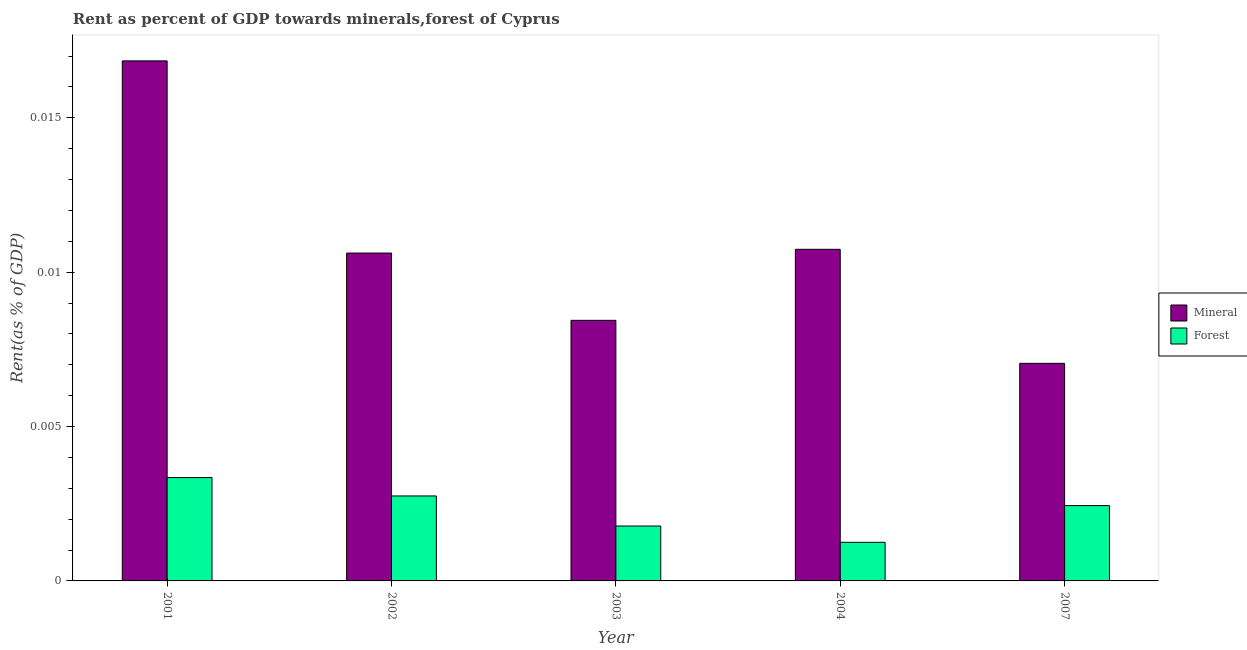How many groups of bars are there?
Offer a very short reply. 5. Are the number of bars per tick equal to the number of legend labels?
Offer a terse response. Yes. What is the label of the 5th group of bars from the left?
Your answer should be compact. 2007. What is the mineral rent in 2004?
Offer a terse response. 0.01. Across all years, what is the maximum forest rent?
Provide a succinct answer. 0. Across all years, what is the minimum mineral rent?
Offer a terse response. 0.01. In which year was the forest rent maximum?
Provide a succinct answer. 2001. In which year was the mineral rent minimum?
Keep it short and to the point. 2007. What is the total mineral rent in the graph?
Keep it short and to the point. 0.05. What is the difference between the forest rent in 2004 and that in 2007?
Provide a succinct answer. -0. What is the difference between the mineral rent in 2002 and the forest rent in 2003?
Ensure brevity in your answer.  0. What is the average mineral rent per year?
Your answer should be very brief. 0.01. In the year 2001, what is the difference between the forest rent and mineral rent?
Your answer should be very brief. 0. In how many years, is the mineral rent greater than 0.005 %?
Keep it short and to the point. 5. What is the ratio of the forest rent in 2001 to that in 2002?
Make the answer very short. 1.22. What is the difference between the highest and the second highest mineral rent?
Provide a short and direct response. 0.01. What is the difference between the highest and the lowest mineral rent?
Offer a terse response. 0.01. In how many years, is the forest rent greater than the average forest rent taken over all years?
Your response must be concise. 3. Is the sum of the mineral rent in 2002 and 2007 greater than the maximum forest rent across all years?
Your answer should be compact. Yes. What does the 1st bar from the left in 2007 represents?
Your answer should be very brief. Mineral. What does the 2nd bar from the right in 2007 represents?
Ensure brevity in your answer.  Mineral. Are all the bars in the graph horizontal?
Your answer should be very brief. No. How many years are there in the graph?
Your answer should be very brief. 5. What is the difference between two consecutive major ticks on the Y-axis?
Your answer should be very brief. 0.01. Are the values on the major ticks of Y-axis written in scientific E-notation?
Ensure brevity in your answer.  No. How are the legend labels stacked?
Your response must be concise. Vertical. What is the title of the graph?
Provide a short and direct response. Rent as percent of GDP towards minerals,forest of Cyprus. Does "Death rate" appear as one of the legend labels in the graph?
Provide a short and direct response. No. What is the label or title of the Y-axis?
Make the answer very short. Rent(as % of GDP). What is the Rent(as % of GDP) of Mineral in 2001?
Offer a very short reply. 0.02. What is the Rent(as % of GDP) in Forest in 2001?
Provide a short and direct response. 0. What is the Rent(as % of GDP) of Mineral in 2002?
Your answer should be compact. 0.01. What is the Rent(as % of GDP) of Forest in 2002?
Keep it short and to the point. 0. What is the Rent(as % of GDP) in Mineral in 2003?
Offer a terse response. 0.01. What is the Rent(as % of GDP) of Forest in 2003?
Your answer should be compact. 0. What is the Rent(as % of GDP) of Mineral in 2004?
Offer a very short reply. 0.01. What is the Rent(as % of GDP) in Forest in 2004?
Your response must be concise. 0. What is the Rent(as % of GDP) of Mineral in 2007?
Keep it short and to the point. 0.01. What is the Rent(as % of GDP) of Forest in 2007?
Provide a succinct answer. 0. Across all years, what is the maximum Rent(as % of GDP) of Mineral?
Keep it short and to the point. 0.02. Across all years, what is the maximum Rent(as % of GDP) in Forest?
Provide a short and direct response. 0. Across all years, what is the minimum Rent(as % of GDP) in Mineral?
Offer a terse response. 0.01. Across all years, what is the minimum Rent(as % of GDP) of Forest?
Make the answer very short. 0. What is the total Rent(as % of GDP) of Mineral in the graph?
Make the answer very short. 0.05. What is the total Rent(as % of GDP) of Forest in the graph?
Make the answer very short. 0.01. What is the difference between the Rent(as % of GDP) of Mineral in 2001 and that in 2002?
Make the answer very short. 0.01. What is the difference between the Rent(as % of GDP) of Forest in 2001 and that in 2002?
Ensure brevity in your answer.  0. What is the difference between the Rent(as % of GDP) in Mineral in 2001 and that in 2003?
Make the answer very short. 0.01. What is the difference between the Rent(as % of GDP) of Forest in 2001 and that in 2003?
Your answer should be compact. 0. What is the difference between the Rent(as % of GDP) in Mineral in 2001 and that in 2004?
Your answer should be compact. 0.01. What is the difference between the Rent(as % of GDP) of Forest in 2001 and that in 2004?
Offer a very short reply. 0. What is the difference between the Rent(as % of GDP) of Mineral in 2001 and that in 2007?
Offer a terse response. 0.01. What is the difference between the Rent(as % of GDP) of Forest in 2001 and that in 2007?
Your answer should be very brief. 0. What is the difference between the Rent(as % of GDP) in Mineral in 2002 and that in 2003?
Your response must be concise. 0. What is the difference between the Rent(as % of GDP) in Mineral in 2002 and that in 2004?
Make the answer very short. -0. What is the difference between the Rent(as % of GDP) of Forest in 2002 and that in 2004?
Make the answer very short. 0. What is the difference between the Rent(as % of GDP) in Mineral in 2002 and that in 2007?
Provide a short and direct response. 0. What is the difference between the Rent(as % of GDP) of Forest in 2002 and that in 2007?
Offer a terse response. 0. What is the difference between the Rent(as % of GDP) in Mineral in 2003 and that in 2004?
Make the answer very short. -0. What is the difference between the Rent(as % of GDP) in Forest in 2003 and that in 2004?
Provide a succinct answer. 0. What is the difference between the Rent(as % of GDP) in Mineral in 2003 and that in 2007?
Give a very brief answer. 0. What is the difference between the Rent(as % of GDP) of Forest in 2003 and that in 2007?
Offer a very short reply. -0. What is the difference between the Rent(as % of GDP) in Mineral in 2004 and that in 2007?
Your answer should be very brief. 0. What is the difference between the Rent(as % of GDP) in Forest in 2004 and that in 2007?
Provide a succinct answer. -0. What is the difference between the Rent(as % of GDP) of Mineral in 2001 and the Rent(as % of GDP) of Forest in 2002?
Keep it short and to the point. 0.01. What is the difference between the Rent(as % of GDP) of Mineral in 2001 and the Rent(as % of GDP) of Forest in 2003?
Your answer should be very brief. 0.02. What is the difference between the Rent(as % of GDP) in Mineral in 2001 and the Rent(as % of GDP) in Forest in 2004?
Make the answer very short. 0.02. What is the difference between the Rent(as % of GDP) of Mineral in 2001 and the Rent(as % of GDP) of Forest in 2007?
Make the answer very short. 0.01. What is the difference between the Rent(as % of GDP) of Mineral in 2002 and the Rent(as % of GDP) of Forest in 2003?
Provide a short and direct response. 0.01. What is the difference between the Rent(as % of GDP) in Mineral in 2002 and the Rent(as % of GDP) in Forest in 2004?
Provide a succinct answer. 0.01. What is the difference between the Rent(as % of GDP) in Mineral in 2002 and the Rent(as % of GDP) in Forest in 2007?
Give a very brief answer. 0.01. What is the difference between the Rent(as % of GDP) in Mineral in 2003 and the Rent(as % of GDP) in Forest in 2004?
Your answer should be very brief. 0.01. What is the difference between the Rent(as % of GDP) of Mineral in 2003 and the Rent(as % of GDP) of Forest in 2007?
Your answer should be very brief. 0.01. What is the difference between the Rent(as % of GDP) in Mineral in 2004 and the Rent(as % of GDP) in Forest in 2007?
Your answer should be compact. 0.01. What is the average Rent(as % of GDP) in Mineral per year?
Ensure brevity in your answer.  0.01. What is the average Rent(as % of GDP) in Forest per year?
Offer a terse response. 0. In the year 2001, what is the difference between the Rent(as % of GDP) in Mineral and Rent(as % of GDP) in Forest?
Give a very brief answer. 0.01. In the year 2002, what is the difference between the Rent(as % of GDP) of Mineral and Rent(as % of GDP) of Forest?
Your answer should be compact. 0.01. In the year 2003, what is the difference between the Rent(as % of GDP) of Mineral and Rent(as % of GDP) of Forest?
Offer a terse response. 0.01. In the year 2004, what is the difference between the Rent(as % of GDP) of Mineral and Rent(as % of GDP) of Forest?
Make the answer very short. 0.01. In the year 2007, what is the difference between the Rent(as % of GDP) of Mineral and Rent(as % of GDP) of Forest?
Your answer should be compact. 0. What is the ratio of the Rent(as % of GDP) in Mineral in 2001 to that in 2002?
Your answer should be compact. 1.59. What is the ratio of the Rent(as % of GDP) of Forest in 2001 to that in 2002?
Ensure brevity in your answer.  1.22. What is the ratio of the Rent(as % of GDP) of Mineral in 2001 to that in 2003?
Provide a succinct answer. 2. What is the ratio of the Rent(as % of GDP) in Forest in 2001 to that in 2003?
Your answer should be very brief. 1.88. What is the ratio of the Rent(as % of GDP) of Mineral in 2001 to that in 2004?
Keep it short and to the point. 1.57. What is the ratio of the Rent(as % of GDP) of Forest in 2001 to that in 2004?
Ensure brevity in your answer.  2.68. What is the ratio of the Rent(as % of GDP) in Mineral in 2001 to that in 2007?
Your answer should be compact. 2.39. What is the ratio of the Rent(as % of GDP) in Forest in 2001 to that in 2007?
Provide a short and direct response. 1.37. What is the ratio of the Rent(as % of GDP) of Mineral in 2002 to that in 2003?
Make the answer very short. 1.26. What is the ratio of the Rent(as % of GDP) in Forest in 2002 to that in 2003?
Your response must be concise. 1.55. What is the ratio of the Rent(as % of GDP) in Mineral in 2002 to that in 2004?
Your answer should be compact. 0.99. What is the ratio of the Rent(as % of GDP) of Forest in 2002 to that in 2004?
Provide a succinct answer. 2.2. What is the ratio of the Rent(as % of GDP) of Mineral in 2002 to that in 2007?
Give a very brief answer. 1.51. What is the ratio of the Rent(as % of GDP) in Forest in 2002 to that in 2007?
Keep it short and to the point. 1.13. What is the ratio of the Rent(as % of GDP) in Mineral in 2003 to that in 2004?
Make the answer very short. 0.79. What is the ratio of the Rent(as % of GDP) in Forest in 2003 to that in 2004?
Make the answer very short. 1.42. What is the ratio of the Rent(as % of GDP) of Mineral in 2003 to that in 2007?
Offer a very short reply. 1.2. What is the ratio of the Rent(as % of GDP) in Forest in 2003 to that in 2007?
Offer a very short reply. 0.73. What is the ratio of the Rent(as % of GDP) of Mineral in 2004 to that in 2007?
Offer a terse response. 1.52. What is the ratio of the Rent(as % of GDP) of Forest in 2004 to that in 2007?
Provide a succinct answer. 0.51. What is the difference between the highest and the second highest Rent(as % of GDP) in Mineral?
Give a very brief answer. 0.01. What is the difference between the highest and the second highest Rent(as % of GDP) of Forest?
Keep it short and to the point. 0. What is the difference between the highest and the lowest Rent(as % of GDP) of Mineral?
Keep it short and to the point. 0.01. What is the difference between the highest and the lowest Rent(as % of GDP) in Forest?
Your answer should be compact. 0. 